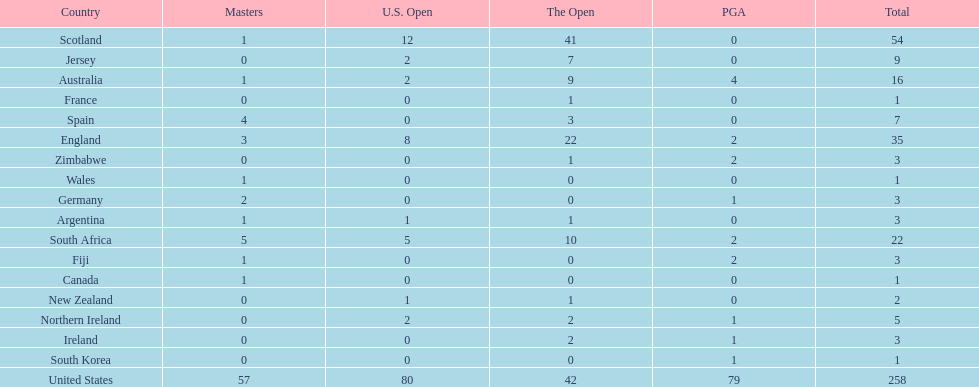How many u.s. open wins does fiji have? 0. 